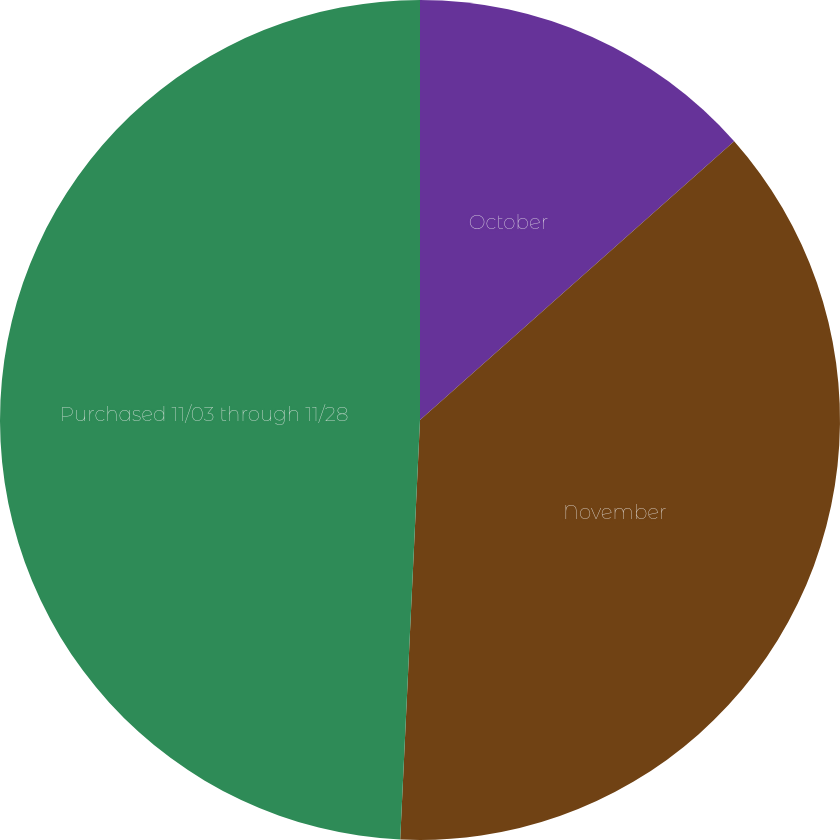Convert chart. <chart><loc_0><loc_0><loc_500><loc_500><pie_chart><fcel>October<fcel>November<fcel>Purchased 11/03 through 11/28<nl><fcel>13.45%<fcel>37.3%<fcel>49.25%<nl></chart> 